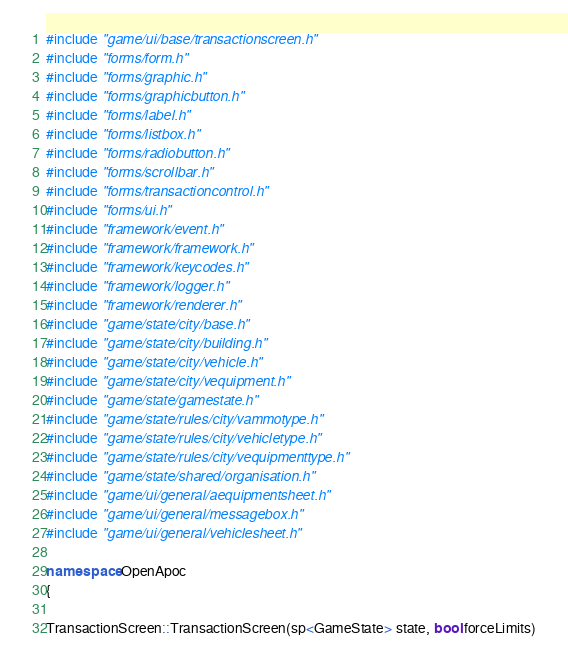Convert code to text. <code><loc_0><loc_0><loc_500><loc_500><_C++_>#include "game/ui/base/transactionscreen.h"
#include "forms/form.h"
#include "forms/graphic.h"
#include "forms/graphicbutton.h"
#include "forms/label.h"
#include "forms/listbox.h"
#include "forms/radiobutton.h"
#include "forms/scrollbar.h"
#include "forms/transactioncontrol.h"
#include "forms/ui.h"
#include "framework/event.h"
#include "framework/framework.h"
#include "framework/keycodes.h"
#include "framework/logger.h"
#include "framework/renderer.h"
#include "game/state/city/base.h"
#include "game/state/city/building.h"
#include "game/state/city/vehicle.h"
#include "game/state/city/vequipment.h"
#include "game/state/gamestate.h"
#include "game/state/rules/city/vammotype.h"
#include "game/state/rules/city/vehicletype.h"
#include "game/state/rules/city/vequipmenttype.h"
#include "game/state/shared/organisation.h"
#include "game/ui/general/aequipmentsheet.h"
#include "game/ui/general/messagebox.h"
#include "game/ui/general/vehiclesheet.h"

namespace OpenApoc
{

TransactionScreen::TransactionScreen(sp<GameState> state, bool forceLimits)</code> 